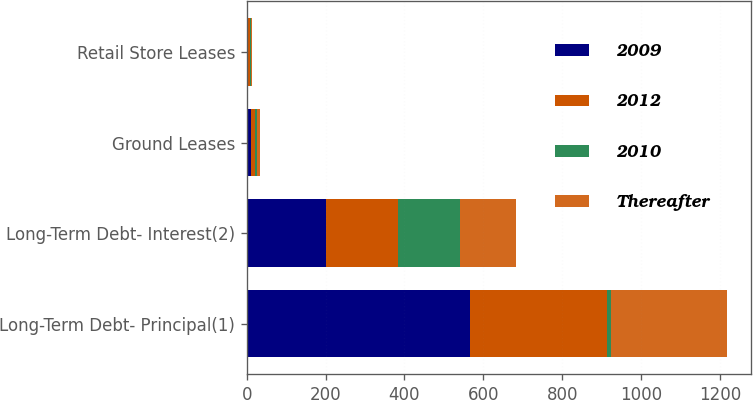Convert chart to OTSL. <chart><loc_0><loc_0><loc_500><loc_500><stacked_bar_chart><ecel><fcel>Long-Term Debt- Principal(1)<fcel>Long-Term Debt- Interest(2)<fcel>Ground Leases<fcel>Retail Store Leases<nl><fcel>2009<fcel>566.7<fcel>200<fcel>10.9<fcel>3.7<nl><fcel>2012<fcel>346.5<fcel>183.4<fcel>8.9<fcel>3.7<nl><fcel>2010<fcel>10.9<fcel>157.5<fcel>6.7<fcel>3.1<nl><fcel>Thereafter<fcel>293.8<fcel>141.2<fcel>6<fcel>2.1<nl></chart> 